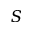Convert formula to latex. <formula><loc_0><loc_0><loc_500><loc_500>S</formula> 